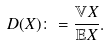Convert formula to latex. <formula><loc_0><loc_0><loc_500><loc_500>D ( X ) \colon = \frac { \mathbb { V } X } { \mathbb { E } X } .</formula> 